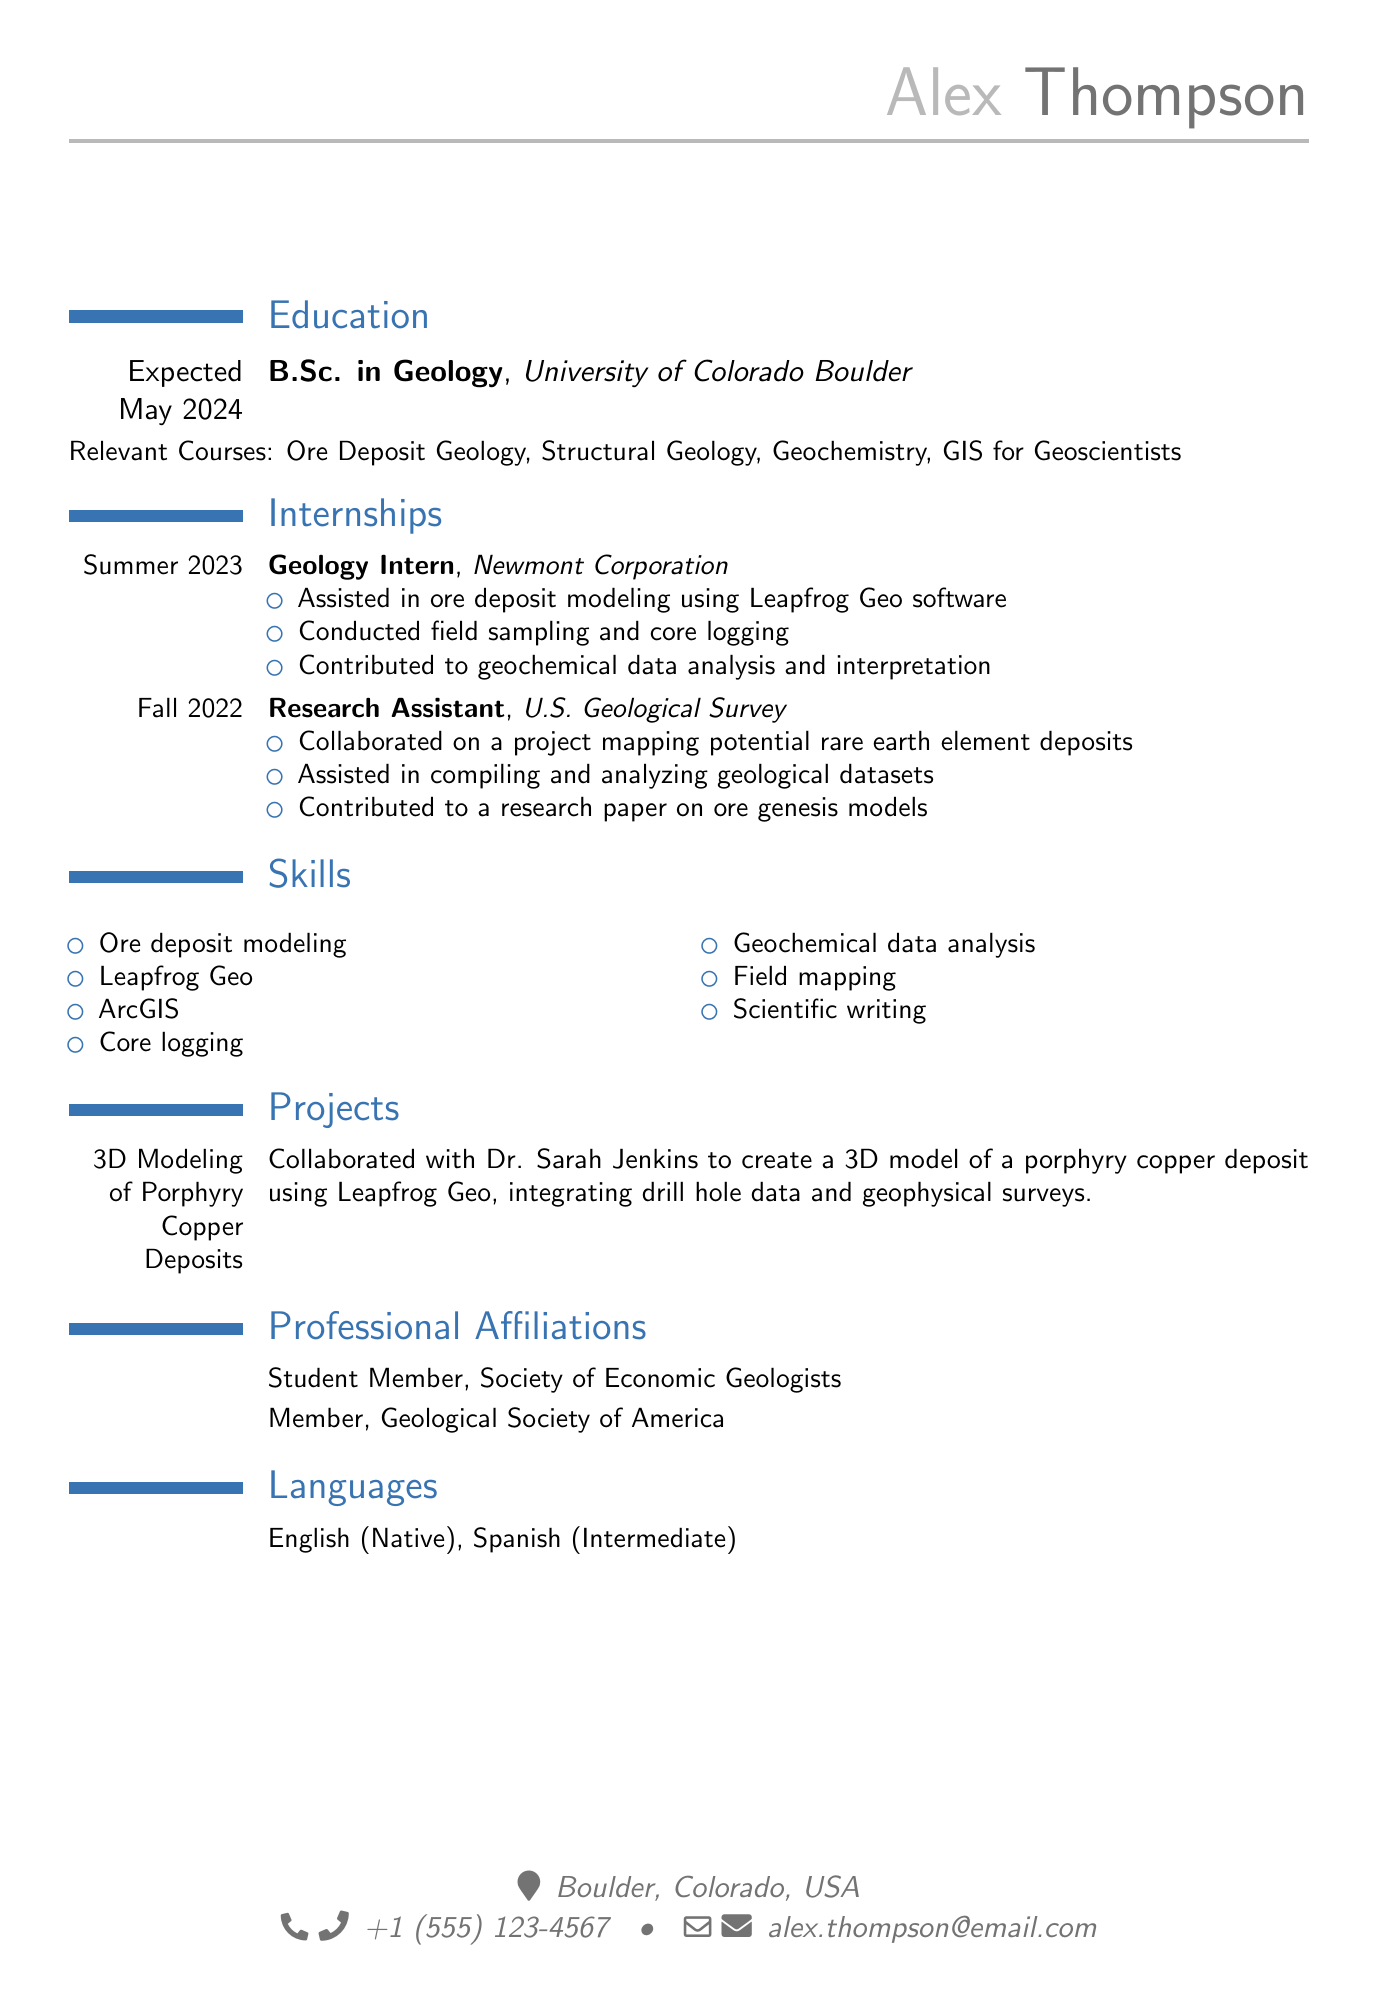what is Alex Thompson's degree? The degree listed in the document is a Bachelor of Science in Geology.
Answer: B.Sc. in Geology what is the expected graduation date? The expected graduation date mentioned in the document is May 2024.
Answer: Expected May 2024 which company did Alex work for as a Geology Intern? The company where Alex worked as a Geology Intern is Newmont Corporation.
Answer: Newmont Corporation what software did Alex use for ore deposit modeling? The software used by Alex for ore deposit modeling is Leapfrog Geo.
Answer: Leapfrog Geo who did Alex collaborate with on the 3D modeling project? Alex collaborated with Dr. Sarah Jenkins on the 3D modeling project.
Answer: Dr. Sarah Jenkins how many internships are listed in the document? The document lists a total of two internships that Alex completed.
Answer: 2 what is one of the relevant courses mentioned in the education section? One of the relevant courses is Ore Deposit Geology.
Answer: Ore Deposit Geology what is Alex's current location? Alex's current location given in the document is Boulder, Colorado, USA.
Answer: Boulder, Colorado, USA what language is Alex intermediate in? The language listed as intermediate is Spanish.
Answer: Spanish 